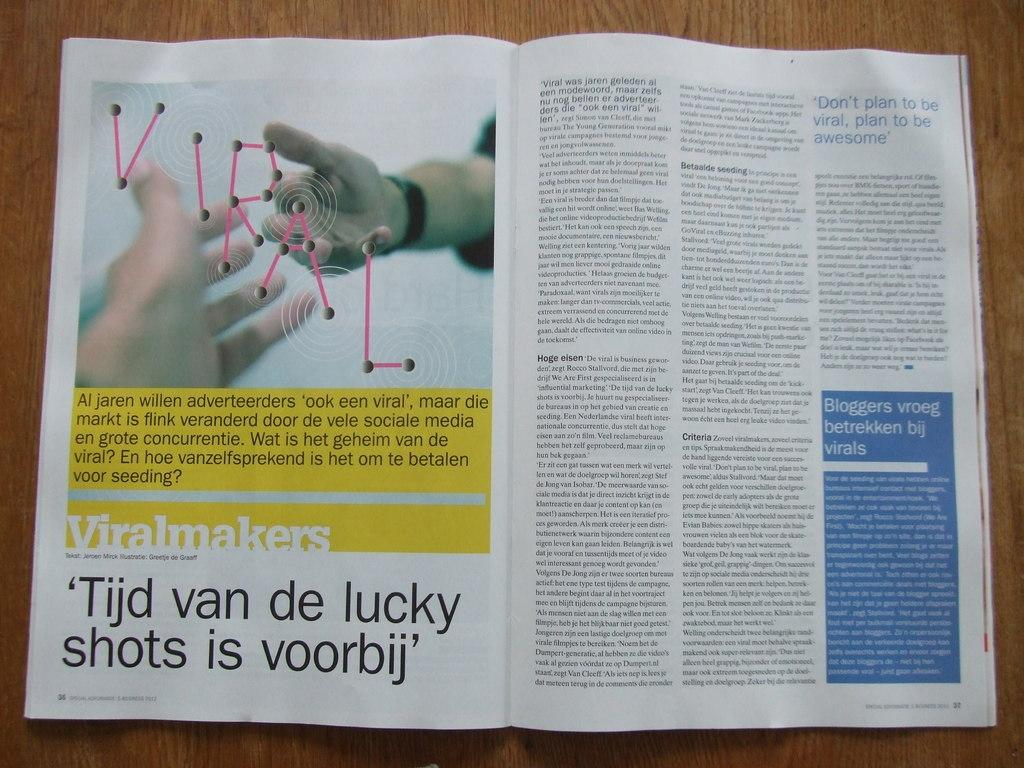Provide a one-sentence caption for the provided image. A open book that is written in German language. 